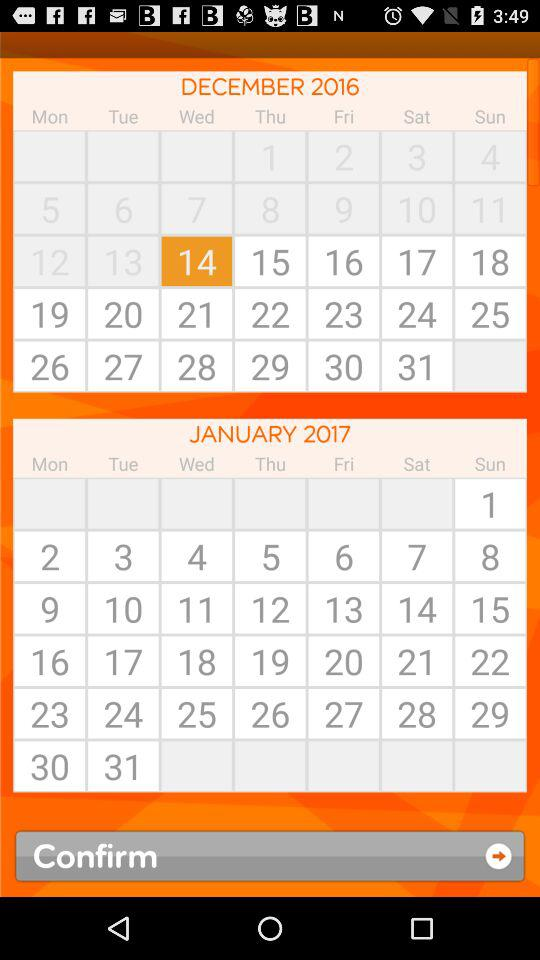Which month's calendar is shown? The calendar shown is for the months of "DECEMBER" and "JANUARY". 